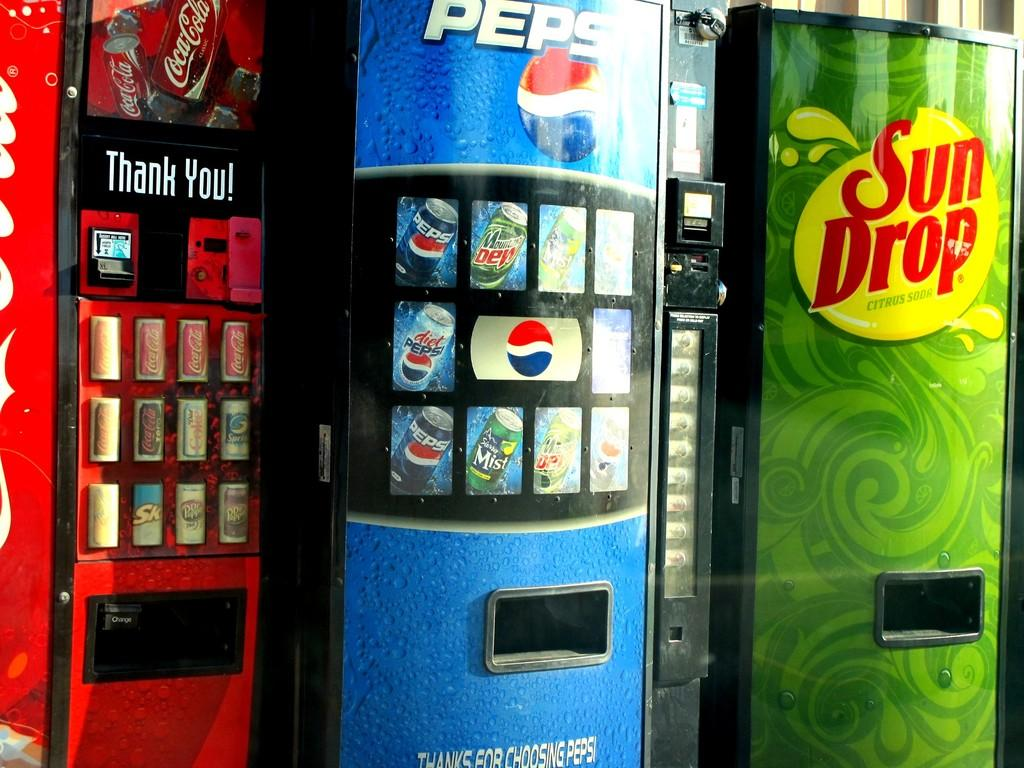<image>
Relay a brief, clear account of the picture shown. The vending machines next to each other with the names Coca Cola, Pepsi, and Sun Drop. 